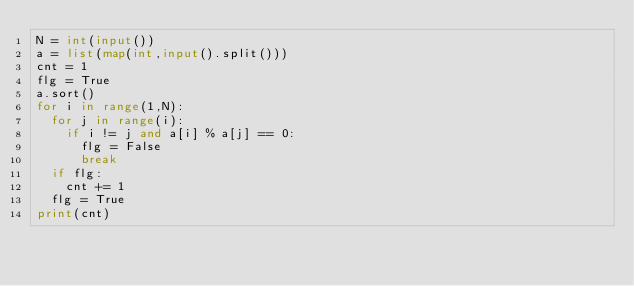<code> <loc_0><loc_0><loc_500><loc_500><_Python_>N = int(input())
a = list(map(int,input().split()))
cnt = 1
flg = True
a.sort()
for i in range(1,N):
  for j in range(i):
    if i != j and a[i] % a[j] == 0:
      flg = False
      break
  if flg:
    cnt += 1
  flg = True
print(cnt)</code> 